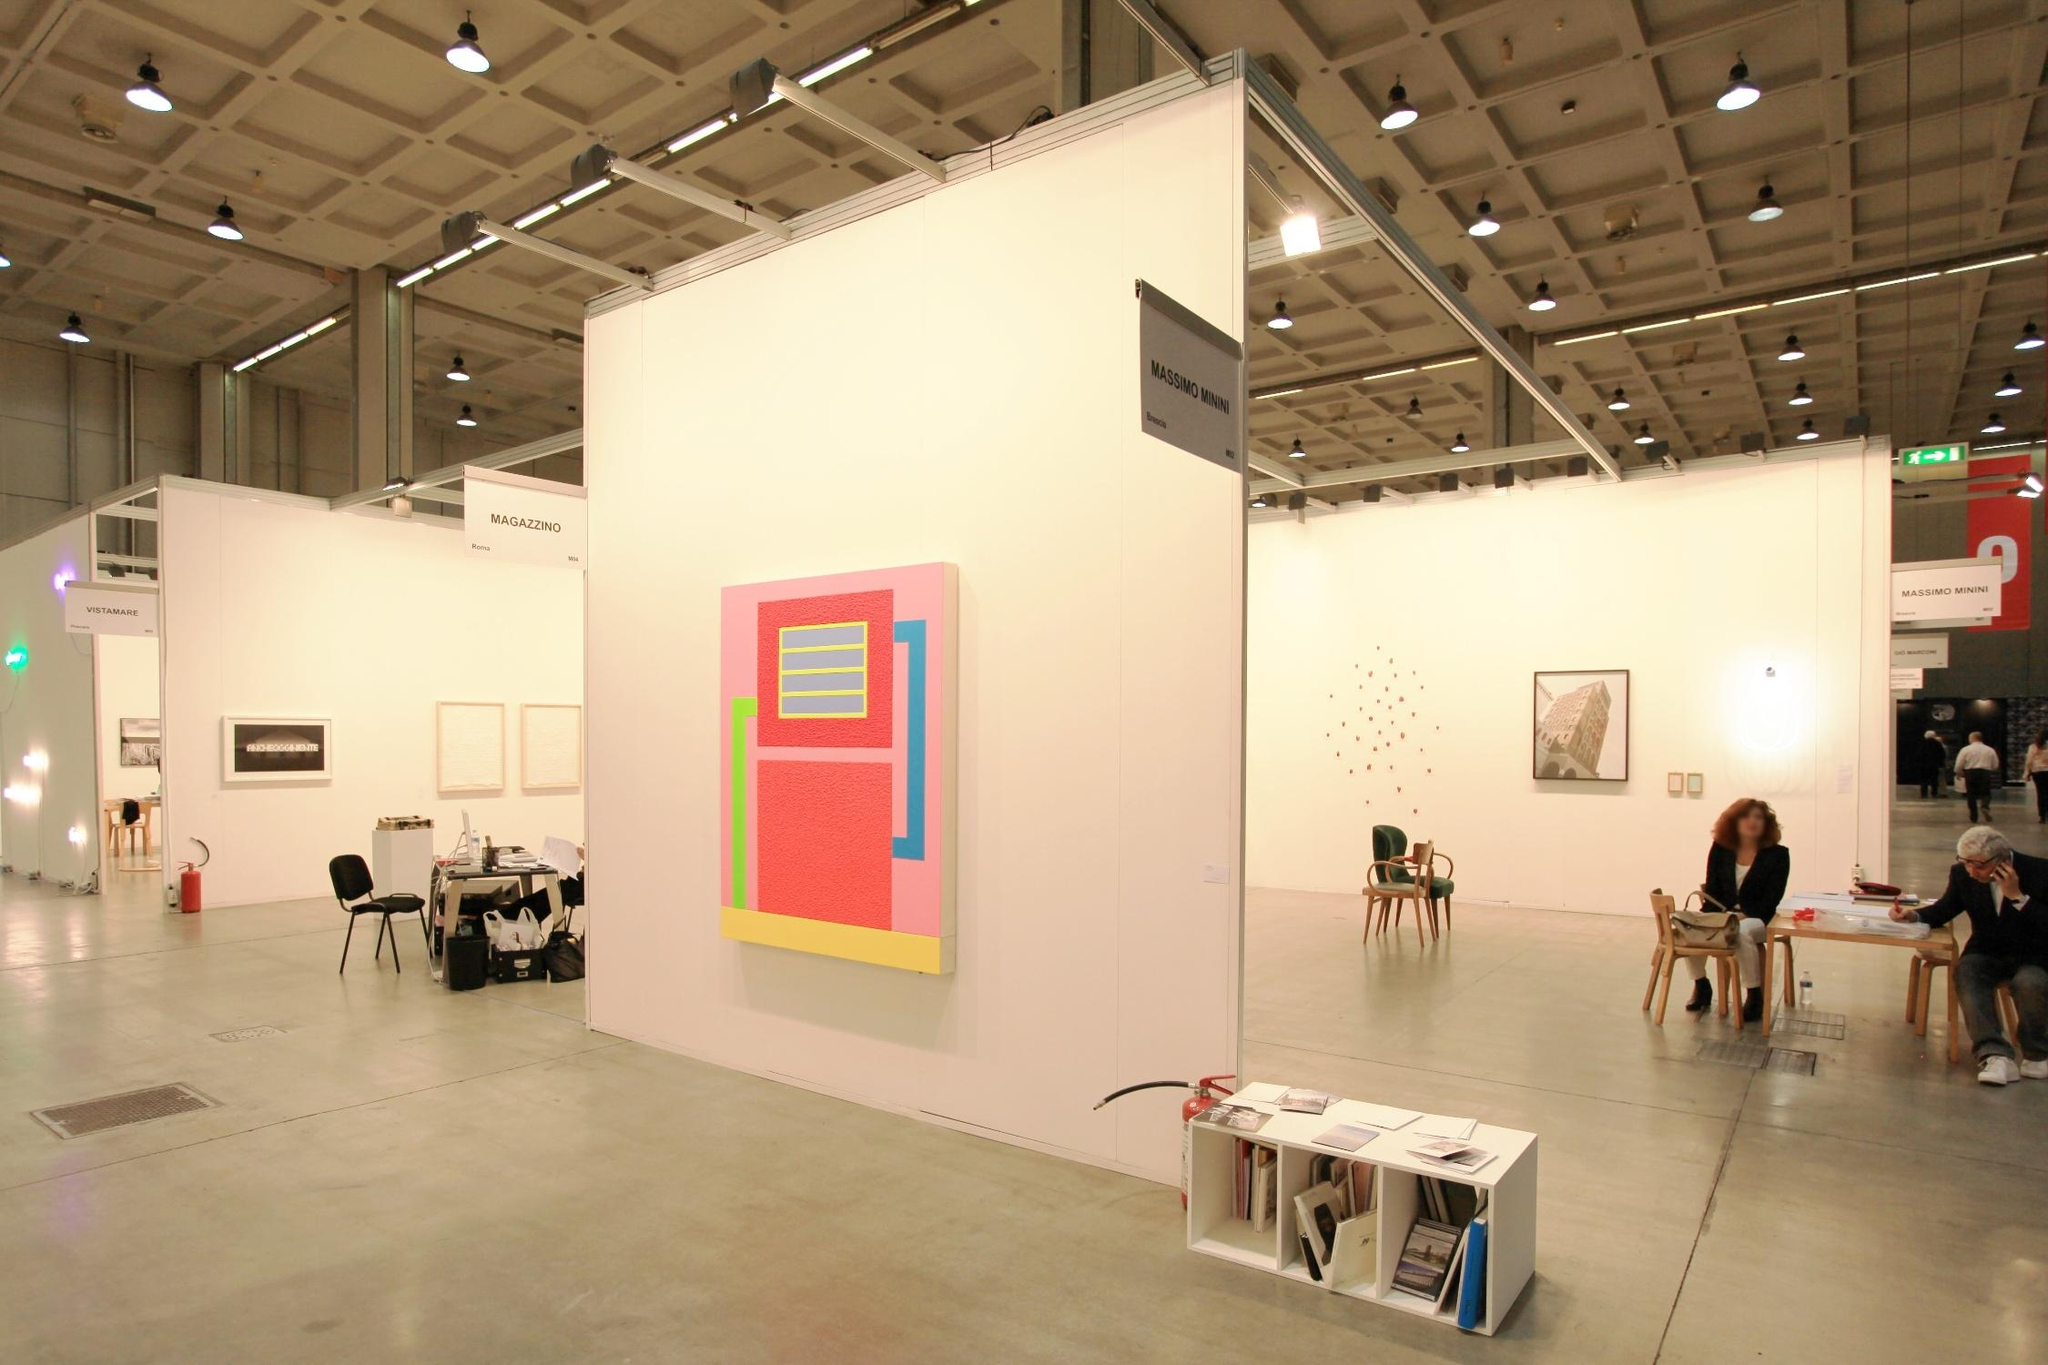Write a detailed description of the given image. The image displays a modern art exhibition within a vast gallery, characterized by its minimalist architecture, featuring high ceilings and a smooth concrete floor. The centerpiece is a large, striking abstract painting mounted on a pristine white wall. This artwork utilizes vibrant colors, with a pink background and a central motif comprising yellow and blue rectangles, possibly hinting at geometric abstraction. Situated around this main piece are other artworks, including small format paintings and possibly kinetic sculptures, suggesting a diverse collection. The setting includes several visitors, indicating an engaging and well-attended exhibition. A strategically placed table in the foreground offers various art-related publications, providing attendees additional insights into the artwork and artists featured at the exhibition. 